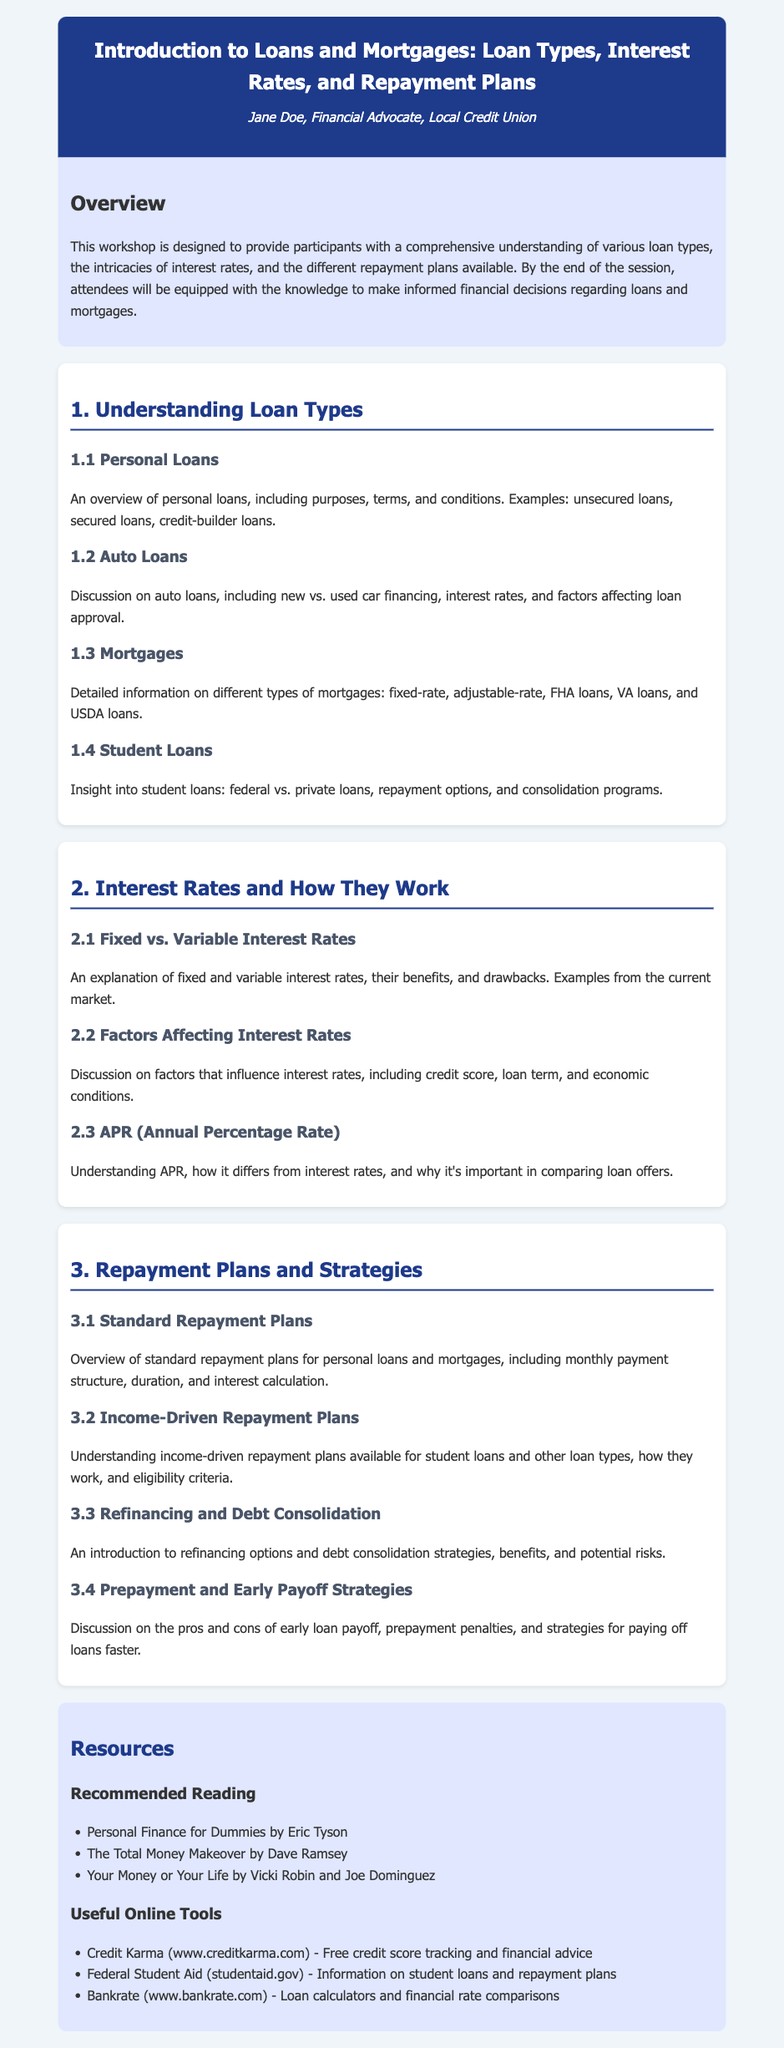What is the title of the workshop? The title is the main heading of the document, which introduces the subject matter being covered.
Answer: Introduction to Loans and Mortgages: Loan Types, Interest Rates, and Repayment Plans Who is the instructor? The instructor is mentioned right below the title, indicating who will be leading the workshop.
Answer: Jane Doe, Financial Advocate, Local Credit Union What is one type of loan discussed in the syllabus? This asks for a specific loan type mentioned under the section detailing loan types.
Answer: Personal Loans What does APR stand for? This is a specific term defined in the section about interest rates, asking for its abbreviated form.
Answer: Annual Percentage Rate Which section covers repayment strategies? This question asks for the main section that deals with repayment plans and strategies related to loans.
Answer: Repayment Plans and Strategies What are income-driven repayment plans available for? This question looks for the specific type of loans that utilize income-driven repayment options as mentioned in the subsection.
Answer: Student loans How many subsections are in the section about loan types? This requires counting the subsections outlined in the loan types section for a numerical response.
Answer: Four Name one recommended reading from the resources. This asks for a specific title from the recommended reading list provided in the resources section.
Answer: Personal Finance for Dummies by Eric Tyson What is discussed in the 2.2 Factors Affecting Interest Rates? This question requires synthesizing information about what is discussed in that subsection.
Answer: Factors that influence interest rates, including credit score, loan term, and economic conditions 